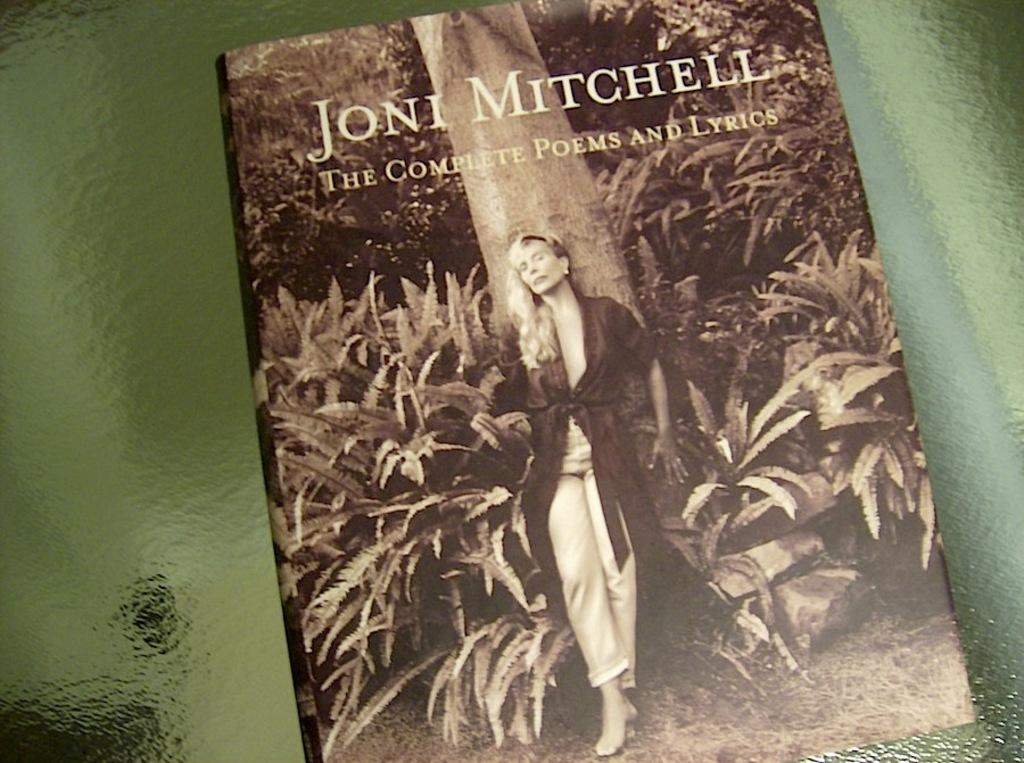<image>
Summarize the visual content of the image. Joni Mitchell has a collection of poems and lyrics. 